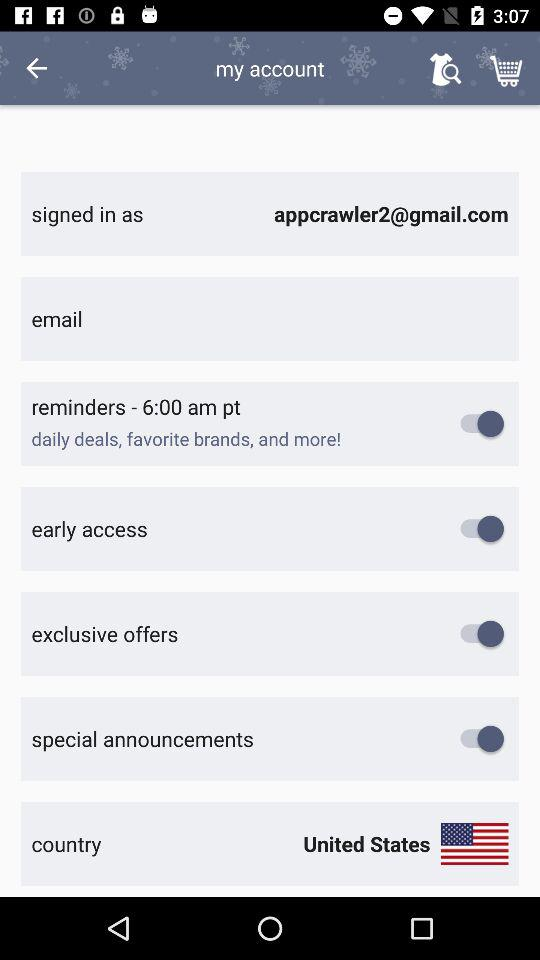What is the current status of "exclusive offers"? The current status is "on". 